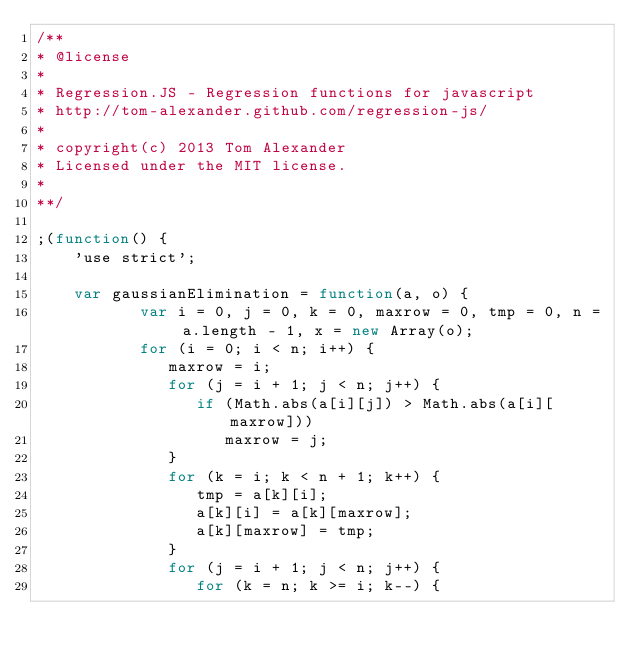<code> <loc_0><loc_0><loc_500><loc_500><_JavaScript_>/**
* @license
*
* Regression.JS - Regression functions for javascript
* http://tom-alexander.github.com/regression-js/
* 
* copyright(c) 2013 Tom Alexander
* Licensed under the MIT license.
*
**/

;(function() {
    'use strict';

    var gaussianElimination = function(a, o) {
           var i = 0, j = 0, k = 0, maxrow = 0, tmp = 0, n = a.length - 1, x = new Array(o);
           for (i = 0; i < n; i++) {
              maxrow = i;
              for (j = i + 1; j < n; j++) {
                 if (Math.abs(a[i][j]) > Math.abs(a[i][maxrow]))
                    maxrow = j;
              }
              for (k = i; k < n + 1; k++) {
                 tmp = a[k][i];
                 a[k][i] = a[k][maxrow];
                 a[k][maxrow] = tmp;
              }
              for (j = i + 1; j < n; j++) {
                 for (k = n; k >= i; k--) {</code> 